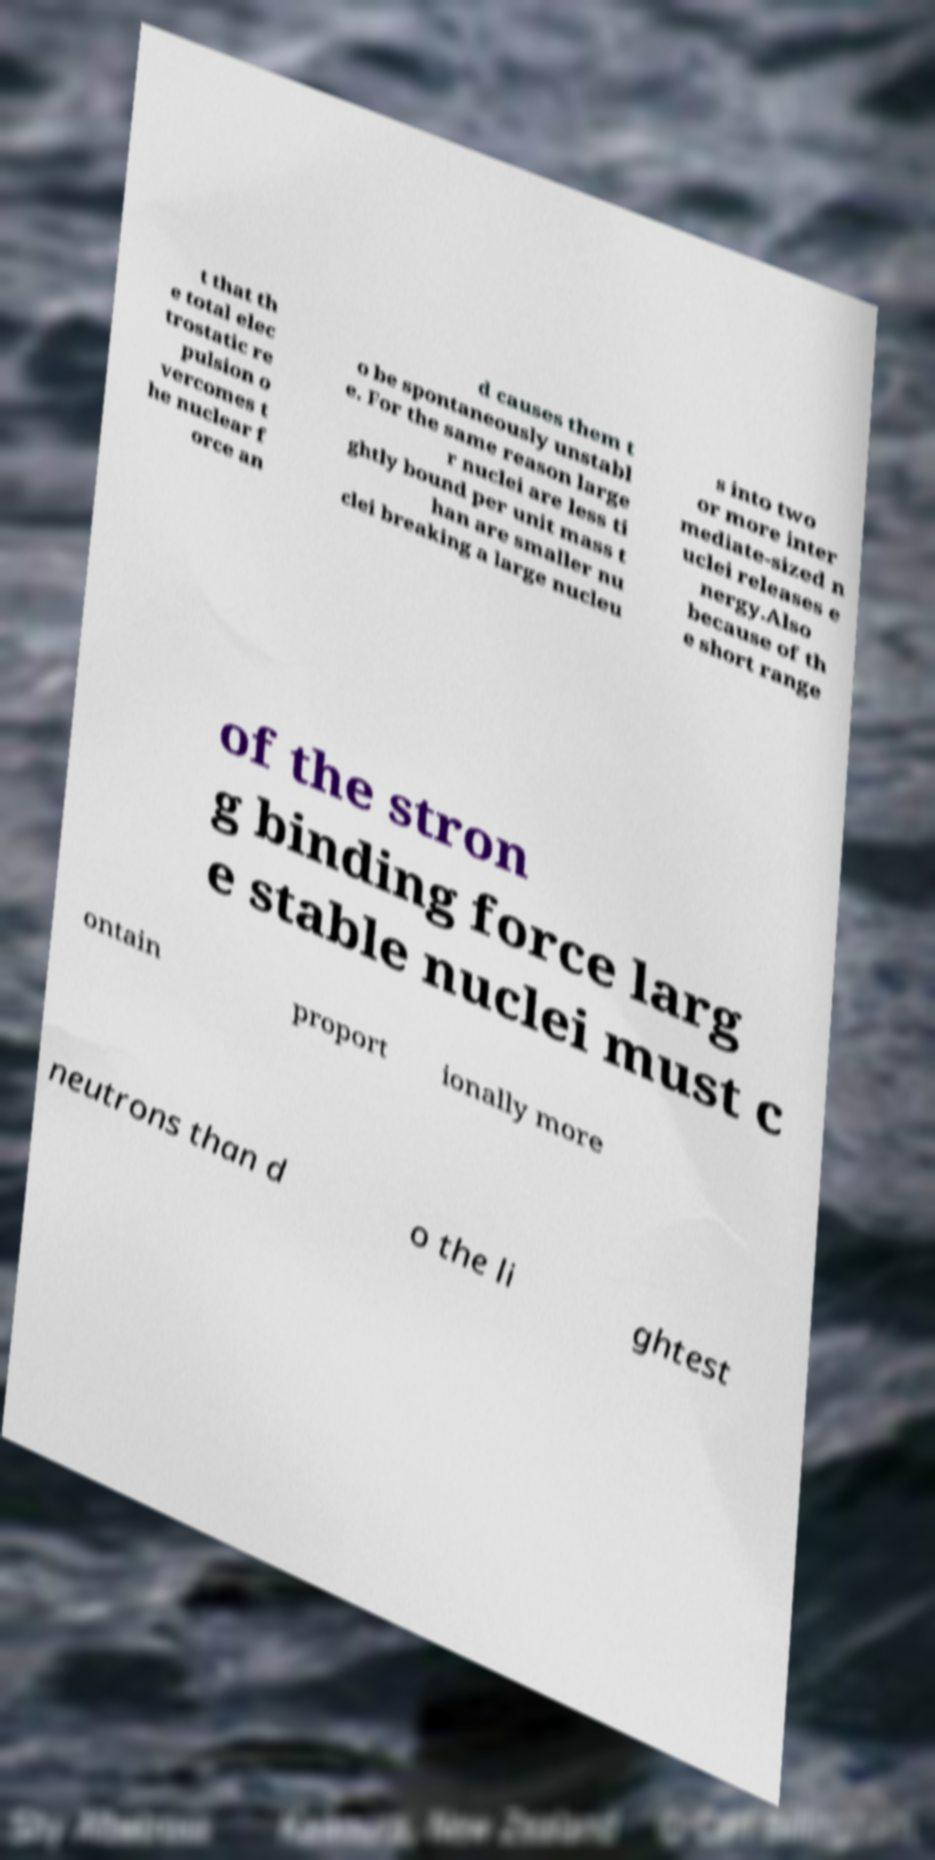What messages or text are displayed in this image? I need them in a readable, typed format. t that th e total elec trostatic re pulsion o vercomes t he nuclear f orce an d causes them t o be spontaneously unstabl e. For the same reason large r nuclei are less ti ghtly bound per unit mass t han are smaller nu clei breaking a large nucleu s into two or more inter mediate-sized n uclei releases e nergy.Also because of th e short range of the stron g binding force larg e stable nuclei must c ontain proport ionally more neutrons than d o the li ghtest 